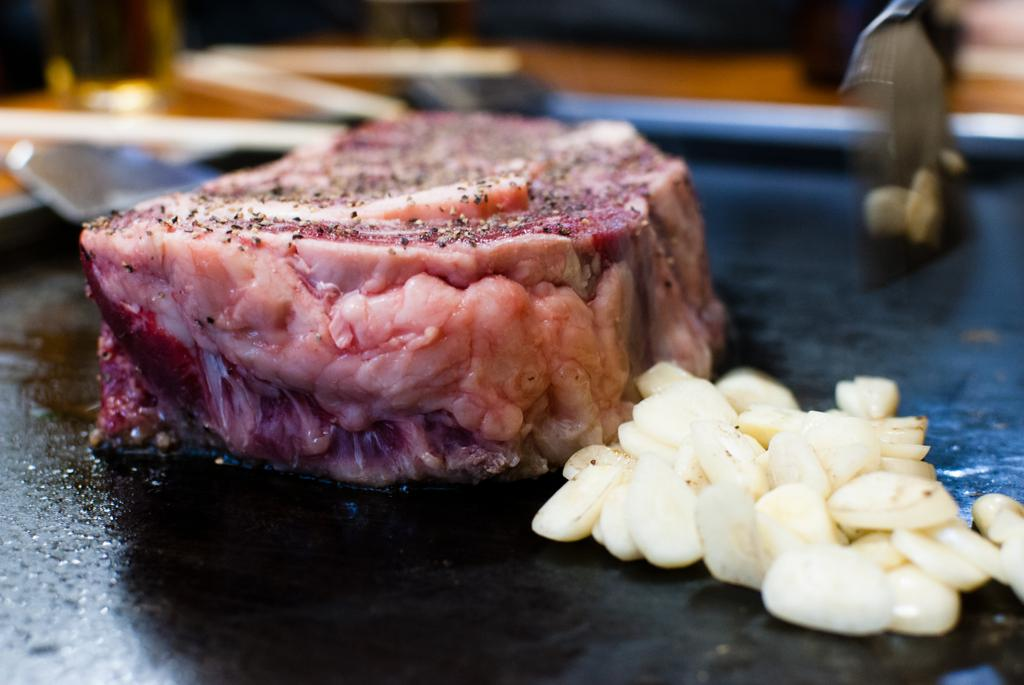What type of food is visible in the image? There is meat in the image. What other ingredient can be seen with the meat? There are garlic pieces in the image. What color is the surface the meat and garlic pieces are on? The surface the meat and garlic pieces are on is black. How would you describe the background of the image? The background of the image is blurred. What type of pancake is being prepared in the image? There is no pancake present in the image; it features meat and garlic pieces on a black surface. What root vegetable is being used to season the meat in the image? There is no root vegetable visible in the image; only meat and garlic pieces are present. 